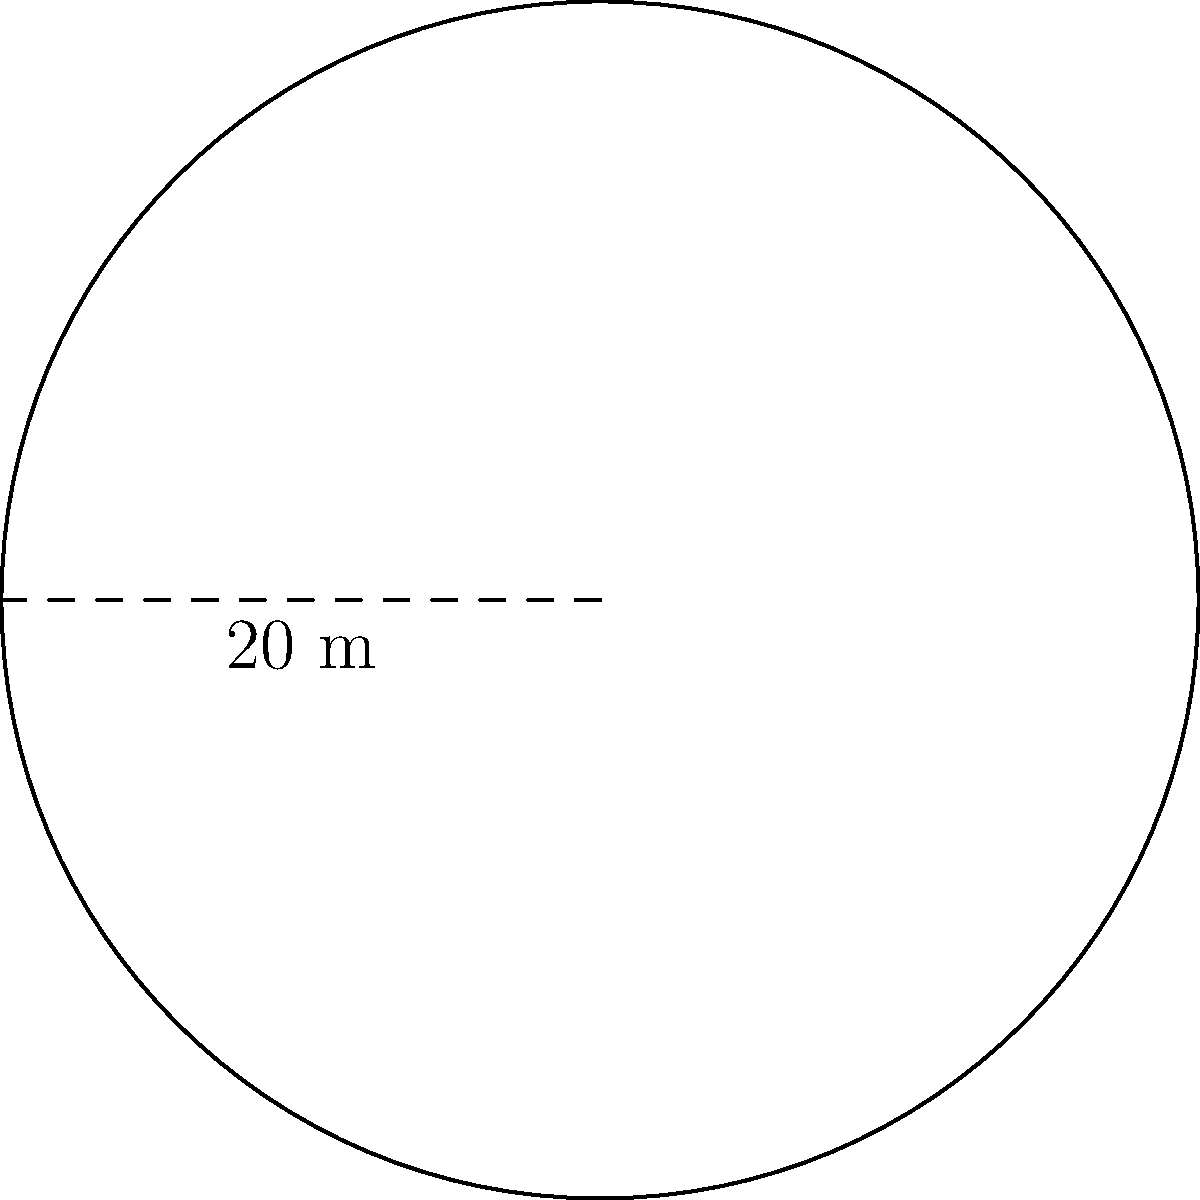As part of a family-friendly urban planning initiative, you're designing a circular playground for children. The diameter of the playground is 20 meters. What is the total area of the playground in square meters? Round your answer to the nearest whole number. To find the area of the circular playground, we'll follow these steps:

1. Identify the given information:
   - The playground is circular
   - The diameter is 20 meters

2. Calculate the radius:
   Radius = Diameter ÷ 2
   Radius = 20 m ÷ 2 = 10 m

3. Use the formula for the area of a circle:
   Area = π * r²
   Where r is the radius

4. Substitute the values:
   Area = π * (10 m)²
   Area = π * 100 m²

5. Calculate:
   Area ≈ 3.14159 * 100 m²
   Area ≈ 314.159 m²

6. Round to the nearest whole number:
   Area ≈ 314 m²

Therefore, the total area of the circular playground is approximately 314 square meters.
Answer: 314 m² 